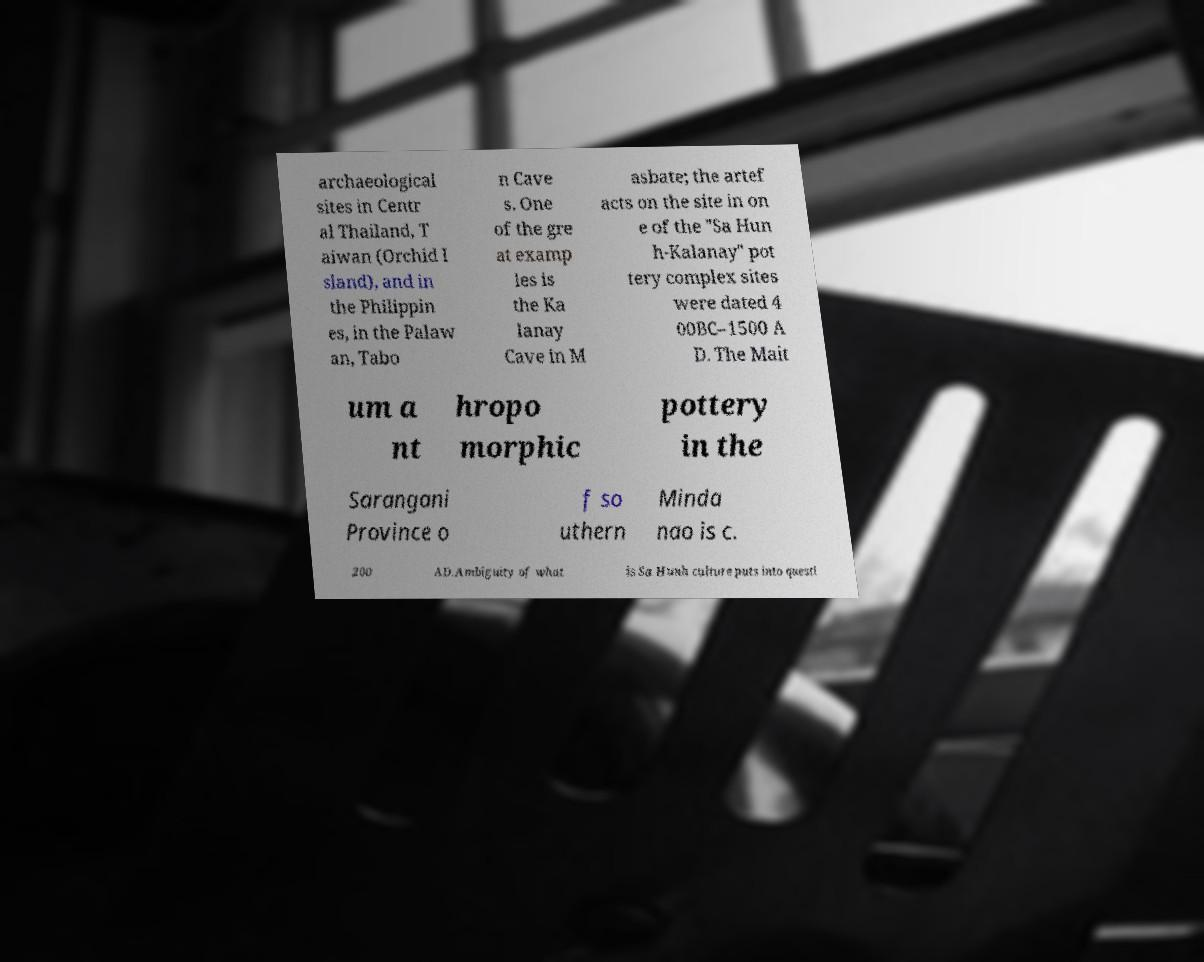What messages or text are displayed in this image? I need them in a readable, typed format. archaeological sites in Centr al Thailand, T aiwan (Orchid I sland), and in the Philippin es, in the Palaw an, Tabo n Cave s. One of the gre at examp les is the Ka lanay Cave in M asbate; the artef acts on the site in on e of the "Sa Hun h-Kalanay" pot tery complex sites were dated 4 00BC–1500 A D. The Mait um a nt hropo morphic pottery in the Sarangani Province o f so uthern Minda nao is c. 200 AD.Ambiguity of what is Sa Hunh culture puts into questi 